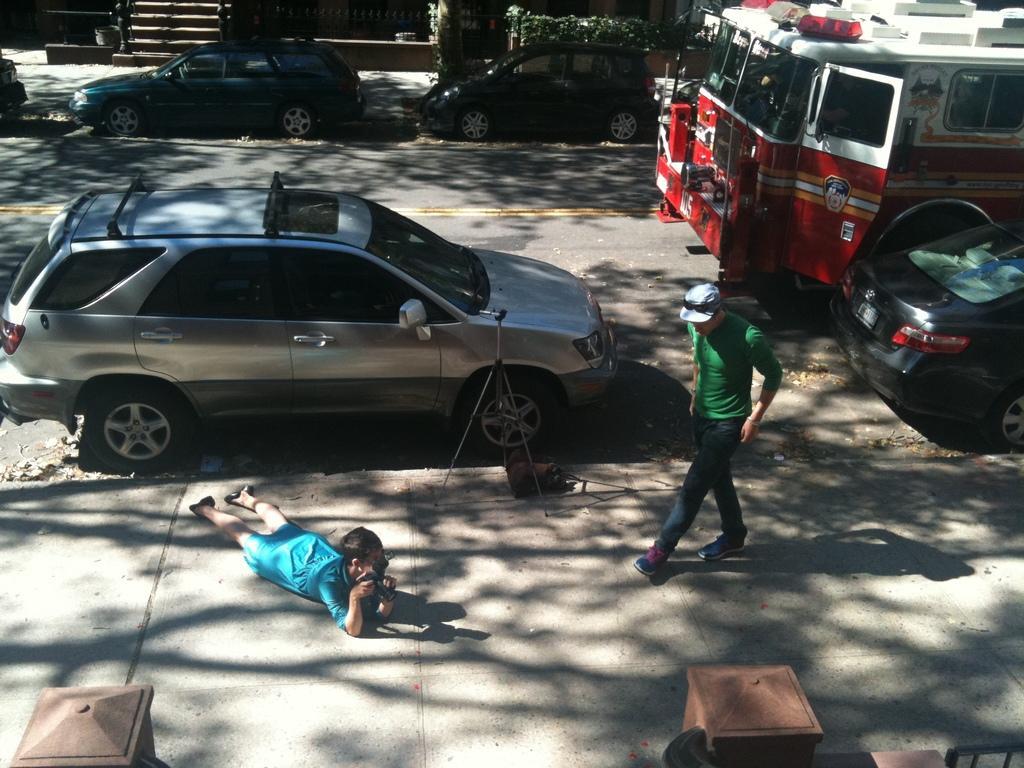Please provide a concise description of this image. In this picture we can see vehicles on the road, tripod stand, two people where a man walking and a person lying on a platform holding camera and in the background we can see plants, steps. 